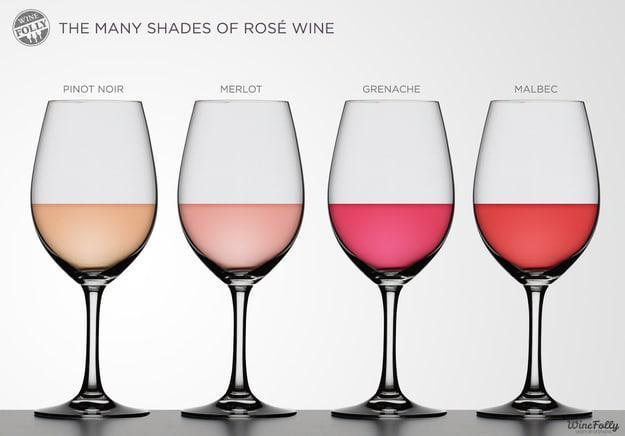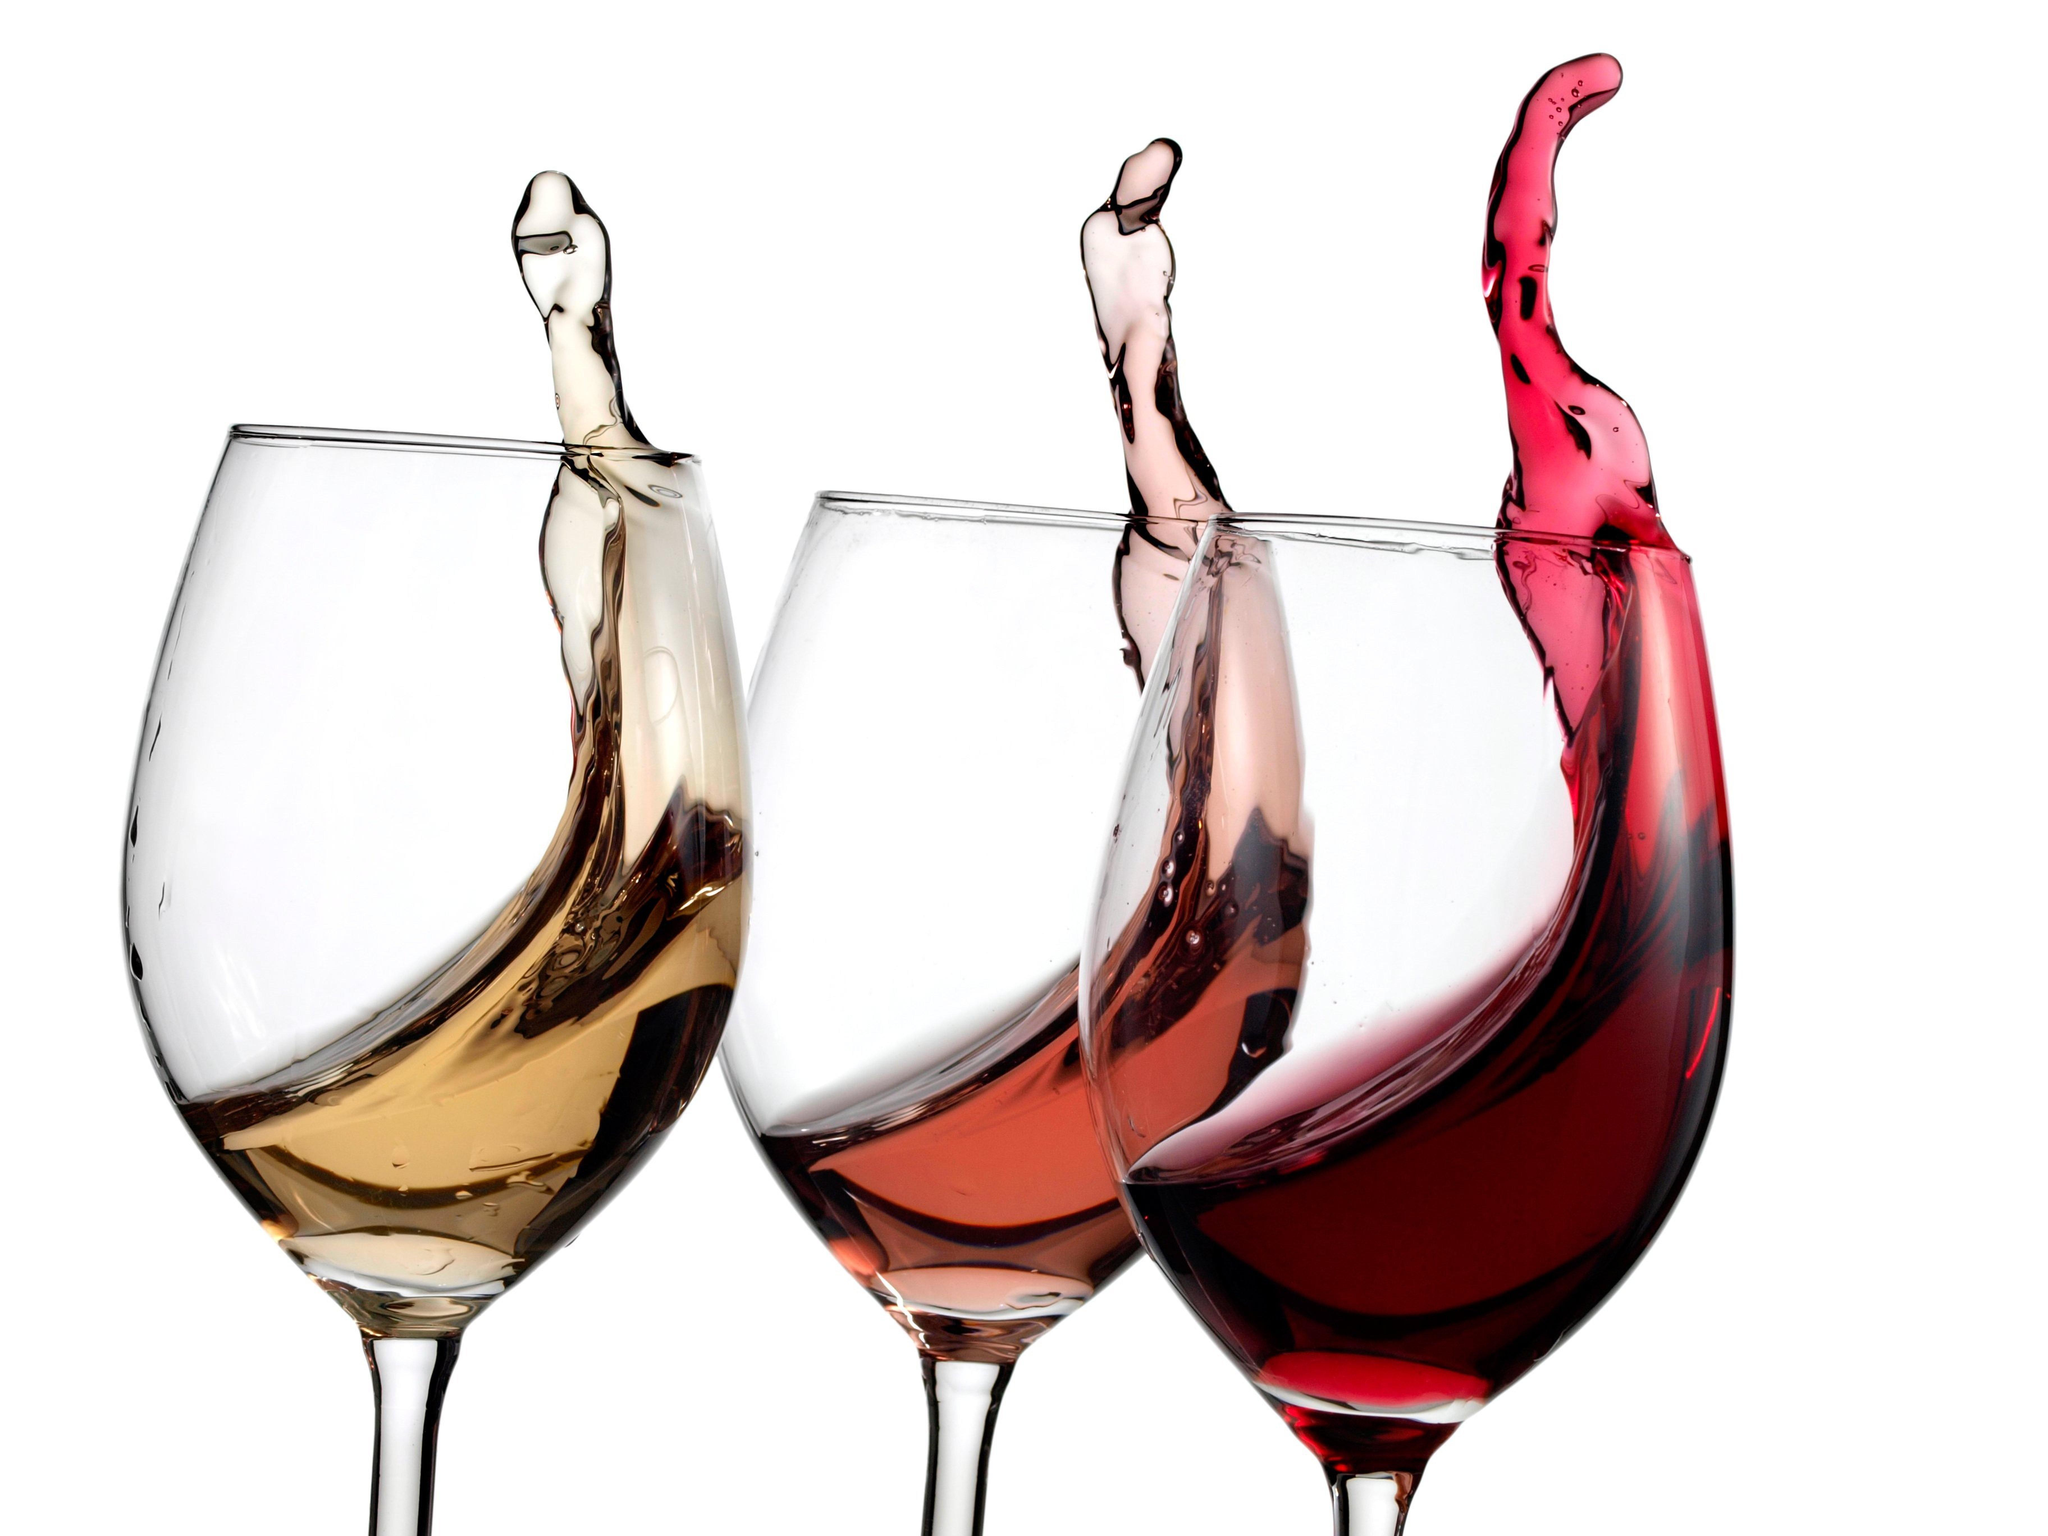The first image is the image on the left, the second image is the image on the right. Given the left and right images, does the statement "There are four glasses of liquid in one of the images." hold true? Answer yes or no. Yes. The first image is the image on the left, the second image is the image on the right. Examine the images to the left and right. Is the description "One image contains four glasses of different colors of wine." accurate? Answer yes or no. Yes. 